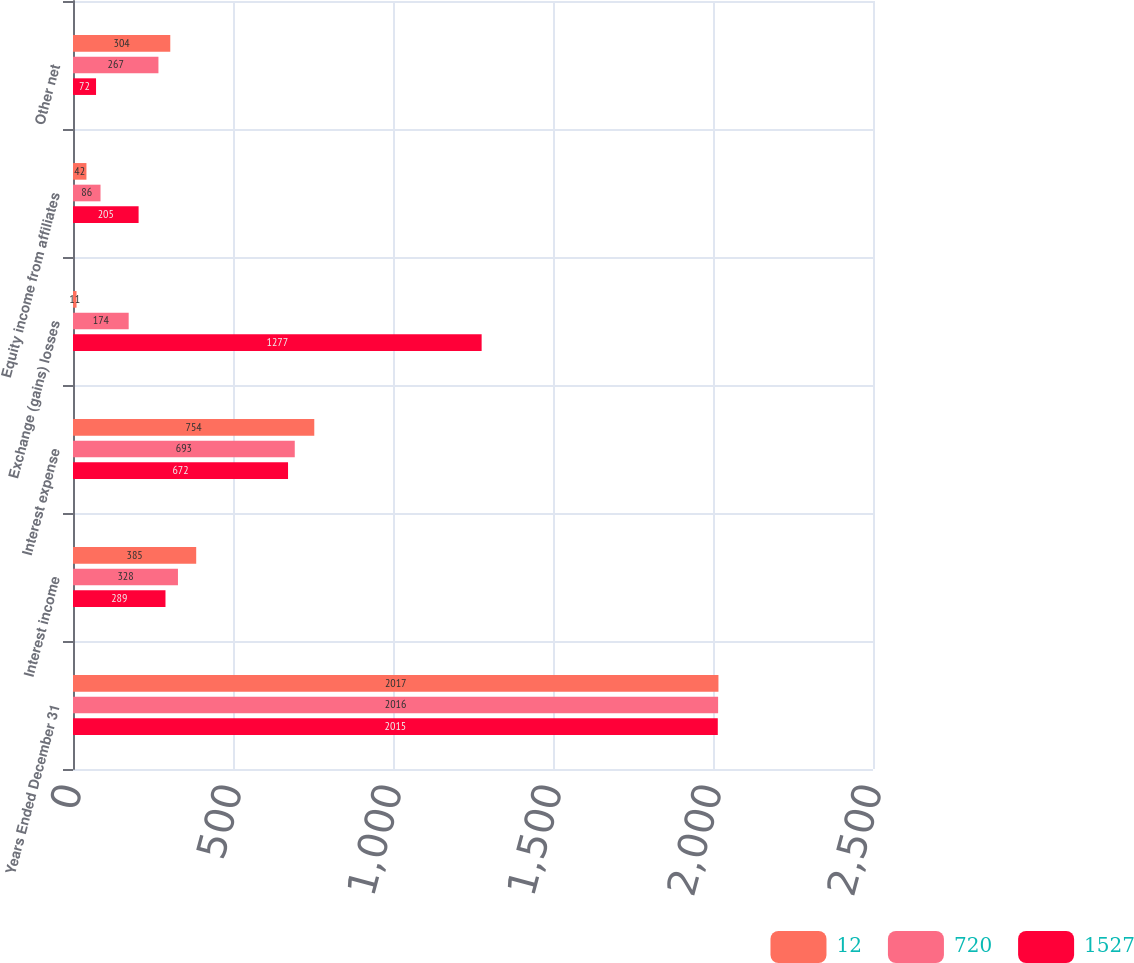Convert chart. <chart><loc_0><loc_0><loc_500><loc_500><stacked_bar_chart><ecel><fcel>Years Ended December 31<fcel>Interest income<fcel>Interest expense<fcel>Exchange (gains) losses<fcel>Equity income from affiliates<fcel>Other net<nl><fcel>12<fcel>2017<fcel>385<fcel>754<fcel>11<fcel>42<fcel>304<nl><fcel>720<fcel>2016<fcel>328<fcel>693<fcel>174<fcel>86<fcel>267<nl><fcel>1527<fcel>2015<fcel>289<fcel>672<fcel>1277<fcel>205<fcel>72<nl></chart> 